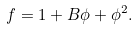<formula> <loc_0><loc_0><loc_500><loc_500>f = 1 + B \phi + \phi ^ { 2 } .</formula> 